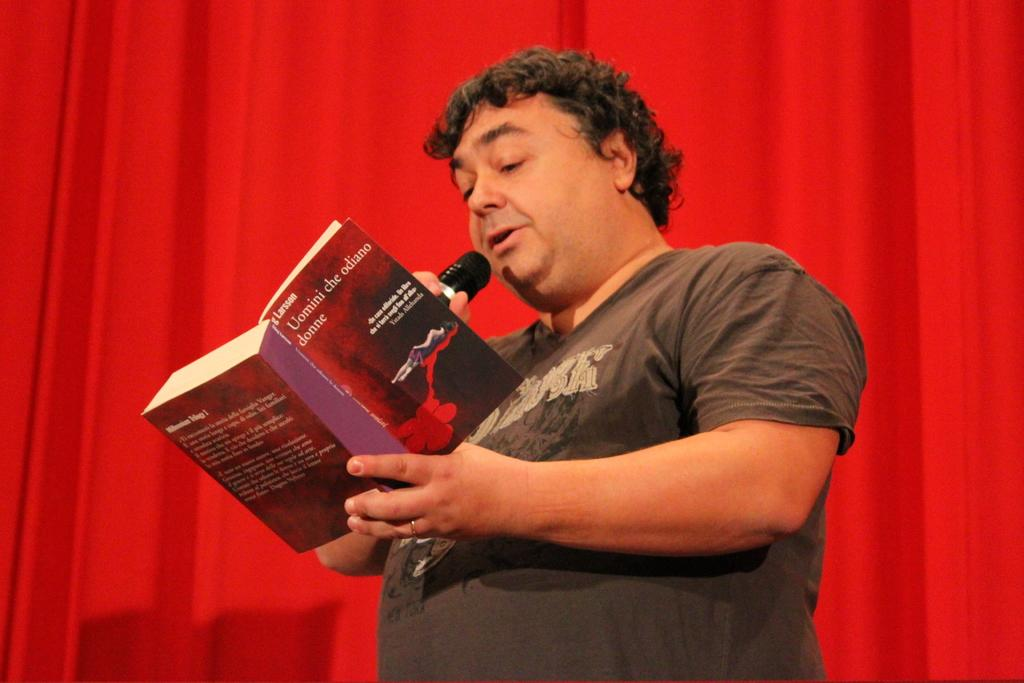Who is present in the image? There is a person in the image. What is the person holding in the image? The person is holding a book. What activity is the person engaged in? The person is talking in front of a microphone. What color cloth can be seen in the image? There is a red color cloth visible in the image. Can you see any waste or garbage in the image? No, there is no waste or garbage visible in the image. Is there a knife present in the image? No, there is no knife present in the image. 